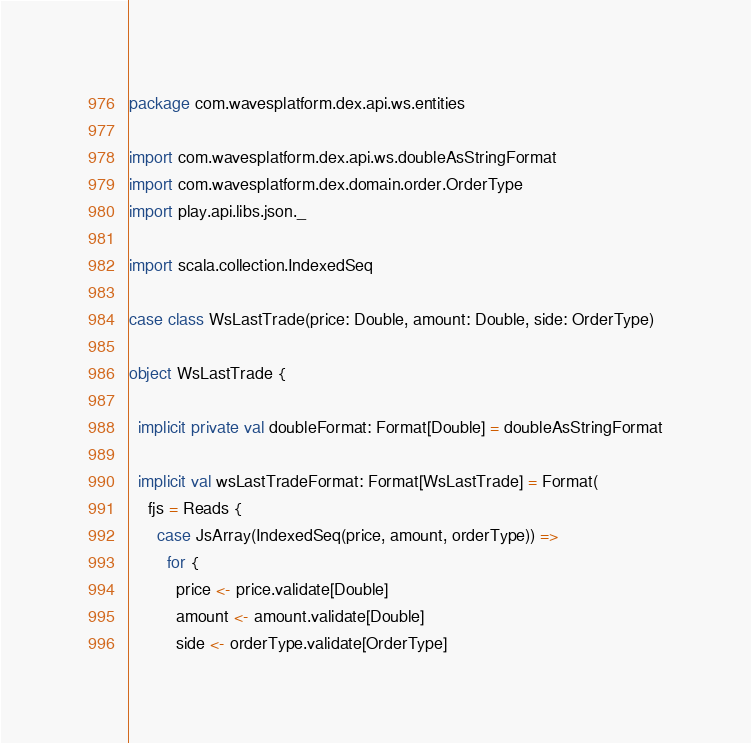Convert code to text. <code><loc_0><loc_0><loc_500><loc_500><_Scala_>package com.wavesplatform.dex.api.ws.entities

import com.wavesplatform.dex.api.ws.doubleAsStringFormat
import com.wavesplatform.dex.domain.order.OrderType
import play.api.libs.json._

import scala.collection.IndexedSeq

case class WsLastTrade(price: Double, amount: Double, side: OrderType)

object WsLastTrade {

  implicit private val doubleFormat: Format[Double] = doubleAsStringFormat

  implicit val wsLastTradeFormat: Format[WsLastTrade] = Format(
    fjs = Reads {
      case JsArray(IndexedSeq(price, amount, orderType)) =>
        for {
          price <- price.validate[Double]
          amount <- amount.validate[Double]
          side <- orderType.validate[OrderType]</code> 